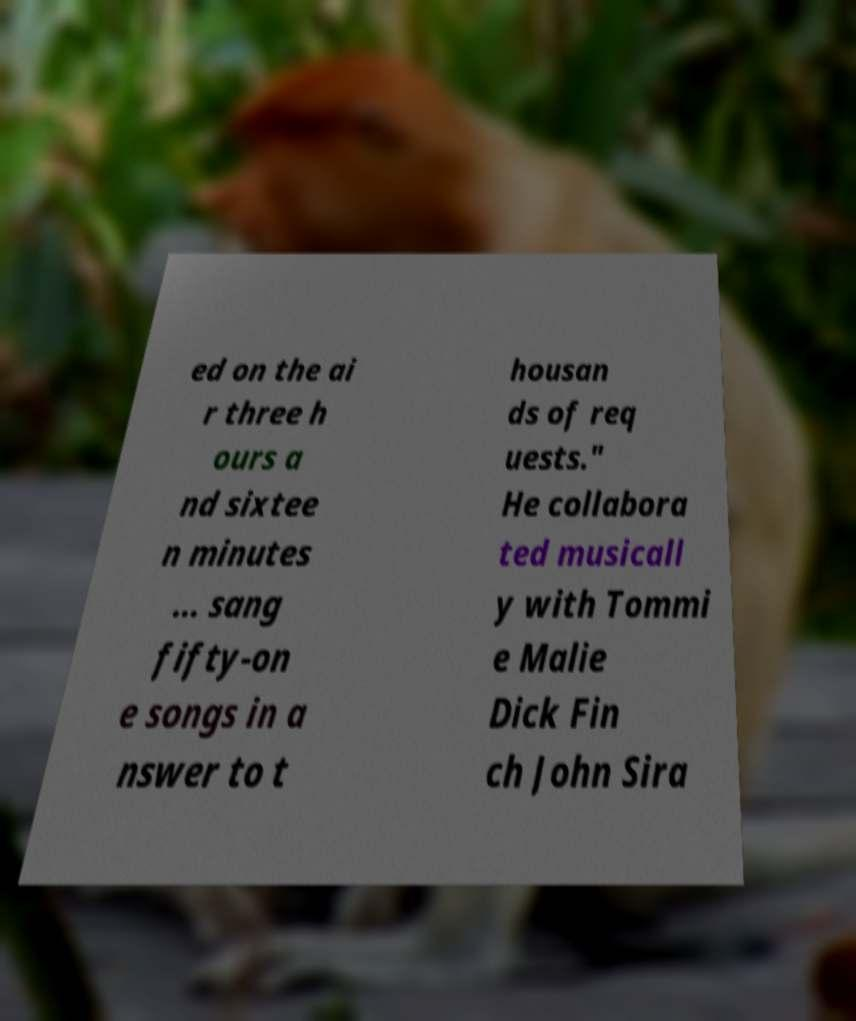Can you read and provide the text displayed in the image?This photo seems to have some interesting text. Can you extract and type it out for me? ed on the ai r three h ours a nd sixtee n minutes ... sang fifty-on e songs in a nswer to t housan ds of req uests." He collabora ted musicall y with Tommi e Malie Dick Fin ch John Sira 